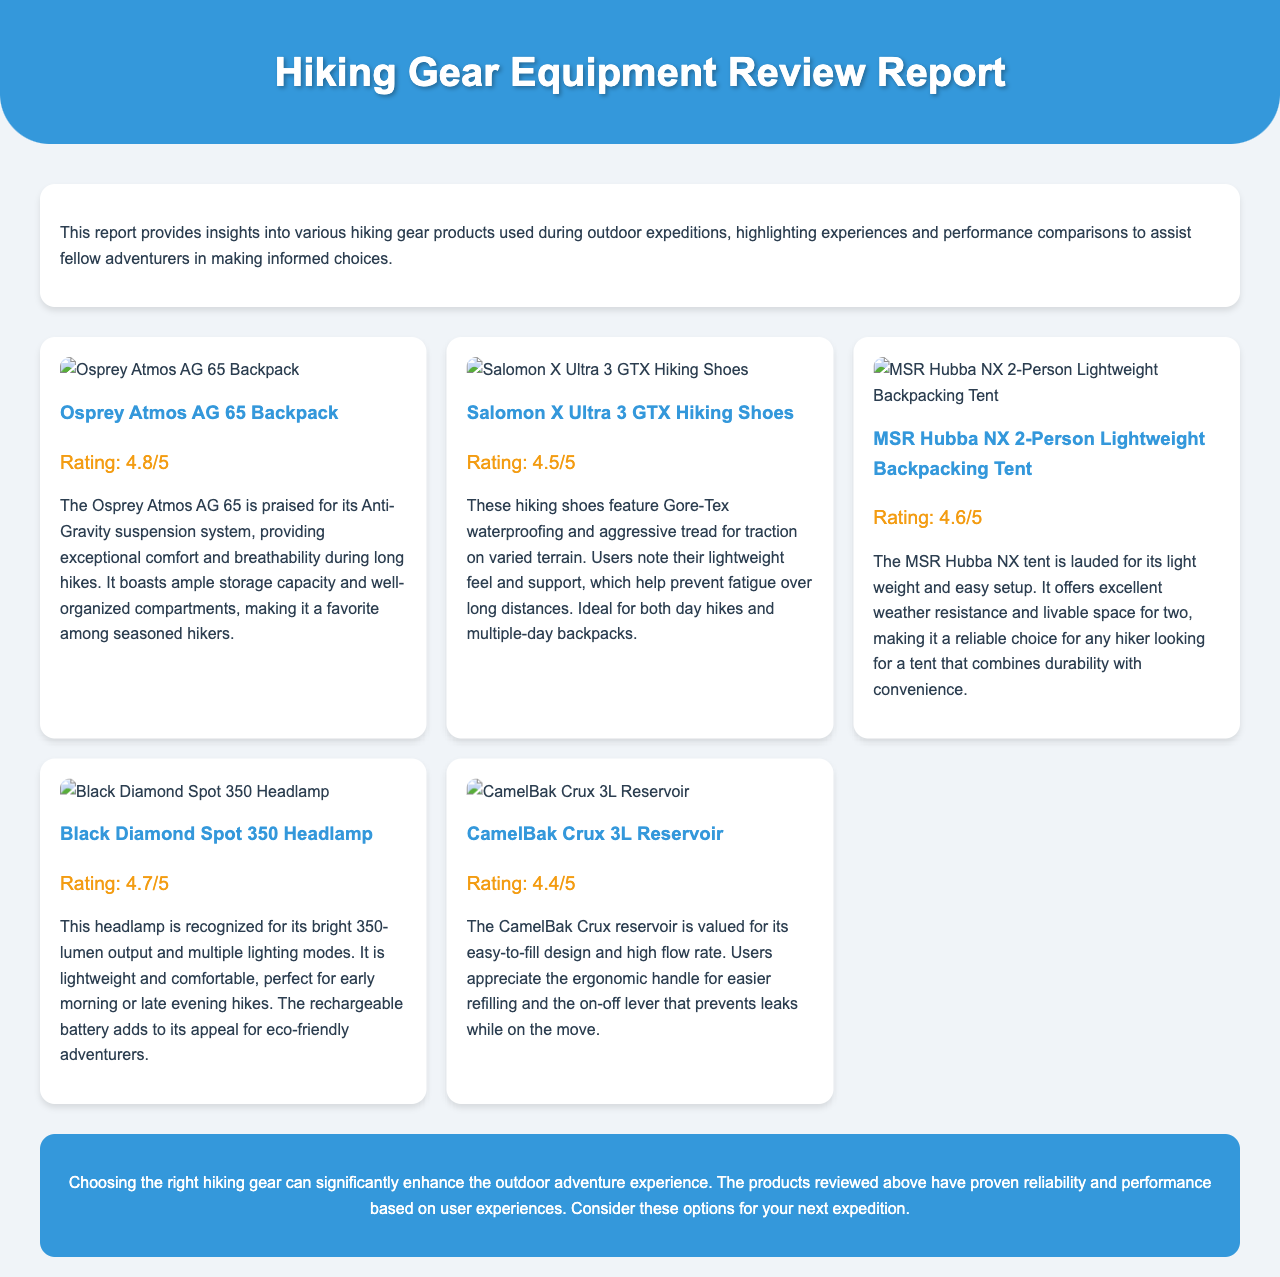what is the highest rated gear? The highest rated gear is the Osprey Atmos AG 65 Backpack with a rating of 4.8.
Answer: Osprey Atmos AG 65 Backpack what image appears for the Salomon X Ultra 3 GTX Hiking Shoes? The image displayed for the Salomon X Ultra 3 GTX Hiking Shoes is linked to "link_to_image_of_salomon_x_ultra_3.jpg".
Answer: link_to_image_of_salomon_x_ultra_3.jpg how many gears are reviewed in total? There are five different hiking gears reviewed in the document.
Answer: 5 which gear is noted for its weather resistance? The gear noted for its weather resistance is the MSR Hubba NX 2-Person Lightweight Backpacking Tent.
Answer: MSR Hubba NX 2-Person Lightweight Backpacking Tent what is a notable feature of the Black Diamond Spot 350 Headlamp? A notable feature of the Black Diamond Spot 350 Headlamp is its bright 350-lumen output and multiple lighting modes.
Answer: 350-lumen output which product is highlighted for preventing leaks while on the move? The product highlighted for preventing leaks while on the move is the CamelBak Crux 3L Reservoir.
Answer: CamelBak Crux 3L Reservoir what do users appreciate about the Osprey Atmos AG 65 Backpack? Users appreciate its exceptional comfort and breathability during long hikes.
Answer: exceptional comfort and breathability what is the main purpose of the document? The main purpose of the document is to provide insights into various hiking gear products used during outdoor expeditions.
Answer: provide insights into various hiking gear products 